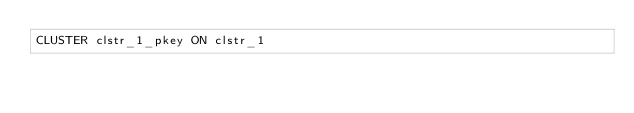<code> <loc_0><loc_0><loc_500><loc_500><_SQL_>CLUSTER clstr_1_pkey ON clstr_1
</code> 